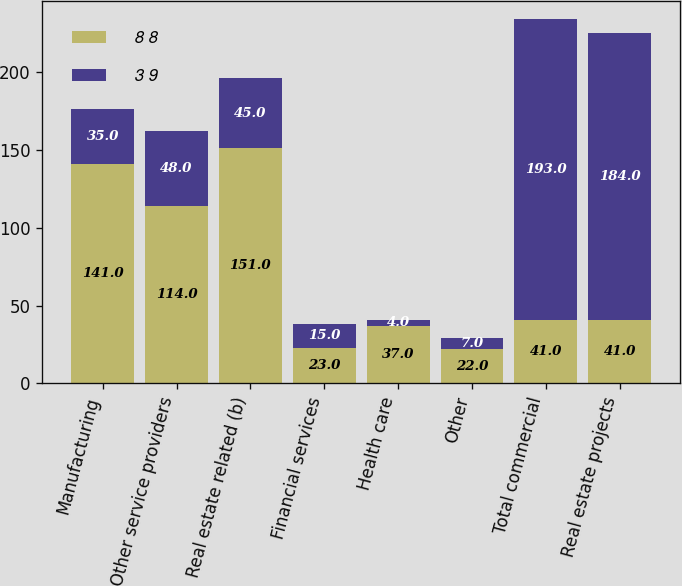<chart> <loc_0><loc_0><loc_500><loc_500><stacked_bar_chart><ecel><fcel>Manufacturing<fcel>Other service providers<fcel>Real estate related (b)<fcel>Financial services<fcel>Health care<fcel>Other<fcel>Total commercial<fcel>Real estate projects<nl><fcel>8 8<fcel>141<fcel>114<fcel>151<fcel>23<fcel>37<fcel>22<fcel>41<fcel>41<nl><fcel>3 9<fcel>35<fcel>48<fcel>45<fcel>15<fcel>4<fcel>7<fcel>193<fcel>184<nl></chart> 